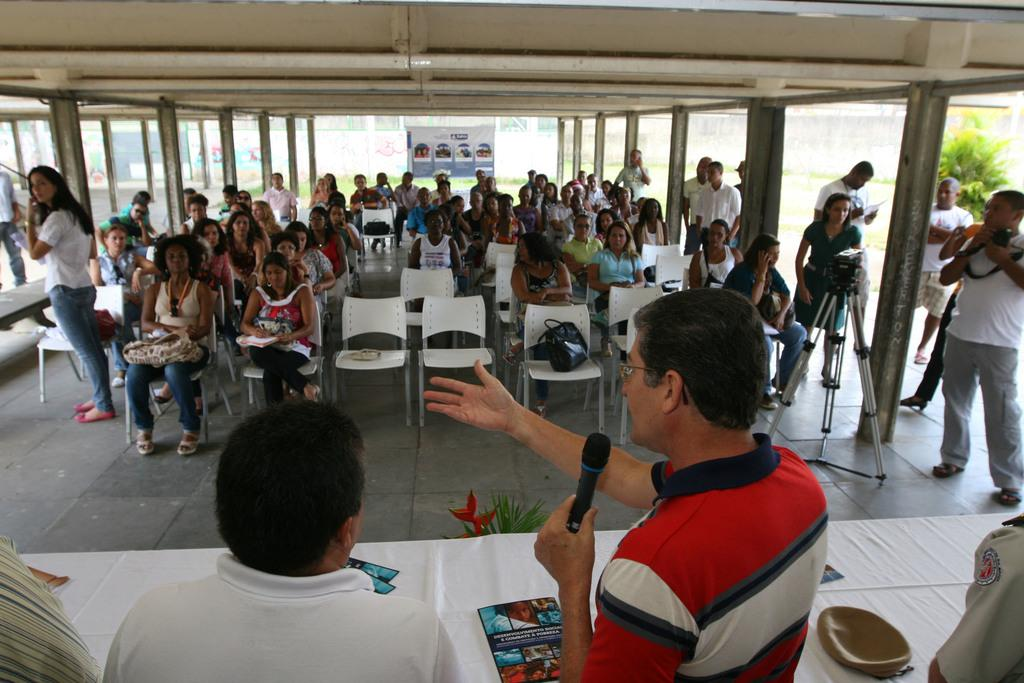Who or what can be seen in the image? There are people in the image. What is present in the image besides the people? There is a table in the image. Can you describe the position of some people in the image? Some people are sitting on chairs in the center of the image. What type of tool is being used by the judge in the image? There is no judge or tool present in the image. What is the wrench used for in the image? There is no wrench present in the image. 